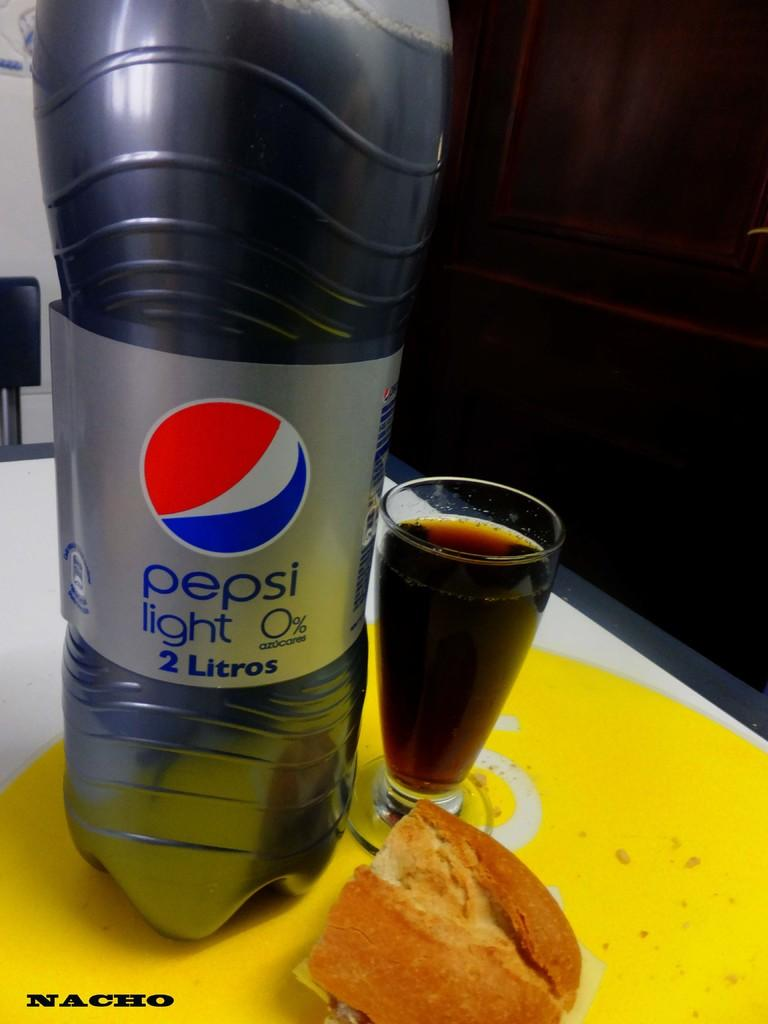What is on the table in the image? There is a drink bottle, a glass with a drink, and food visible on the table. Can you describe the drink bottle? The drink bottle is on the table. What type of drink is in the glass? The provided facts do not specify the type of drink in the glass. What kind of food is visible on the table? The provided facts do not specify the type of food on the table. Where are the dolls playing in the image? There are no dolls present in the image. What type of cemetery can be seen in the background of the image? There is no cemetery visible in the image; it only shows a table with a drink bottle, a glass with a drink, and food. 